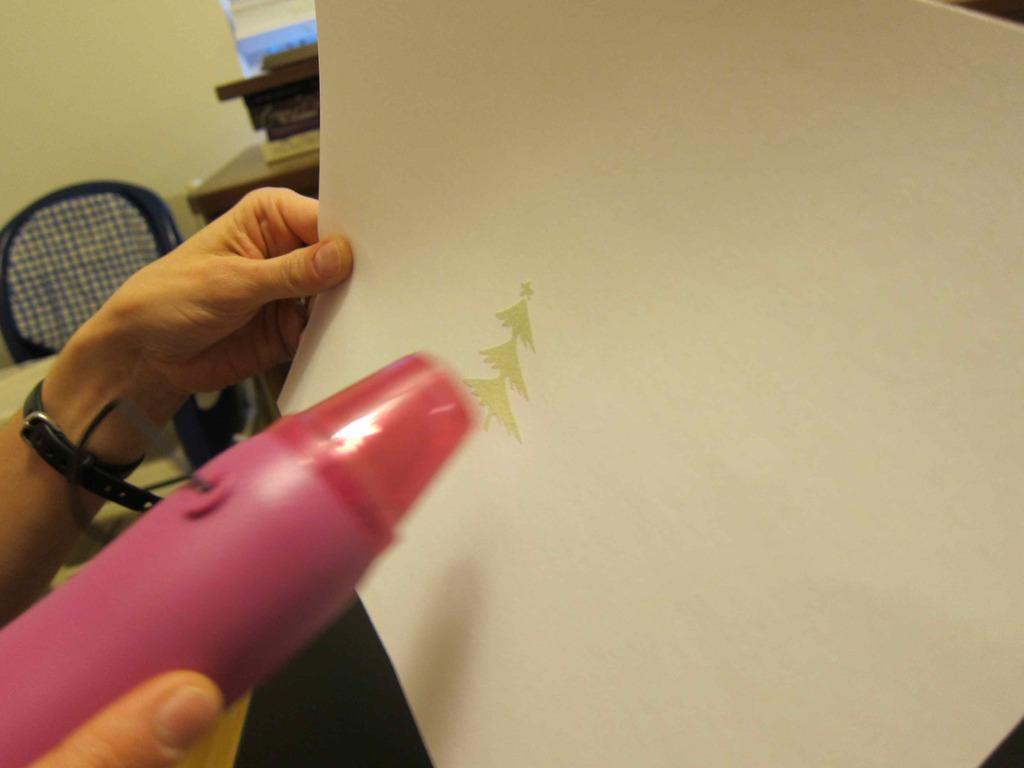Describe this image in one or two sentences. In this picture we can see a person's hands, this person is holding a bottle and a pen, in the background we can see a table, a chair and a wall. 